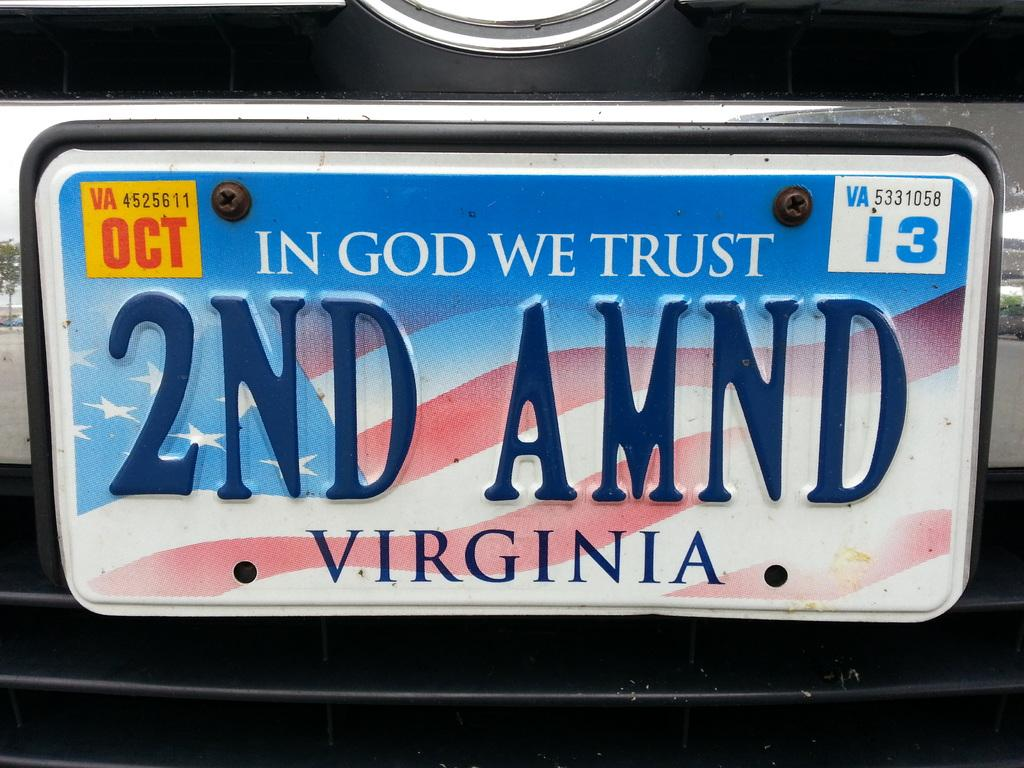Provide a one-sentence caption for the provided image. A Virginia license plate with "In God We Trust" at the top. 